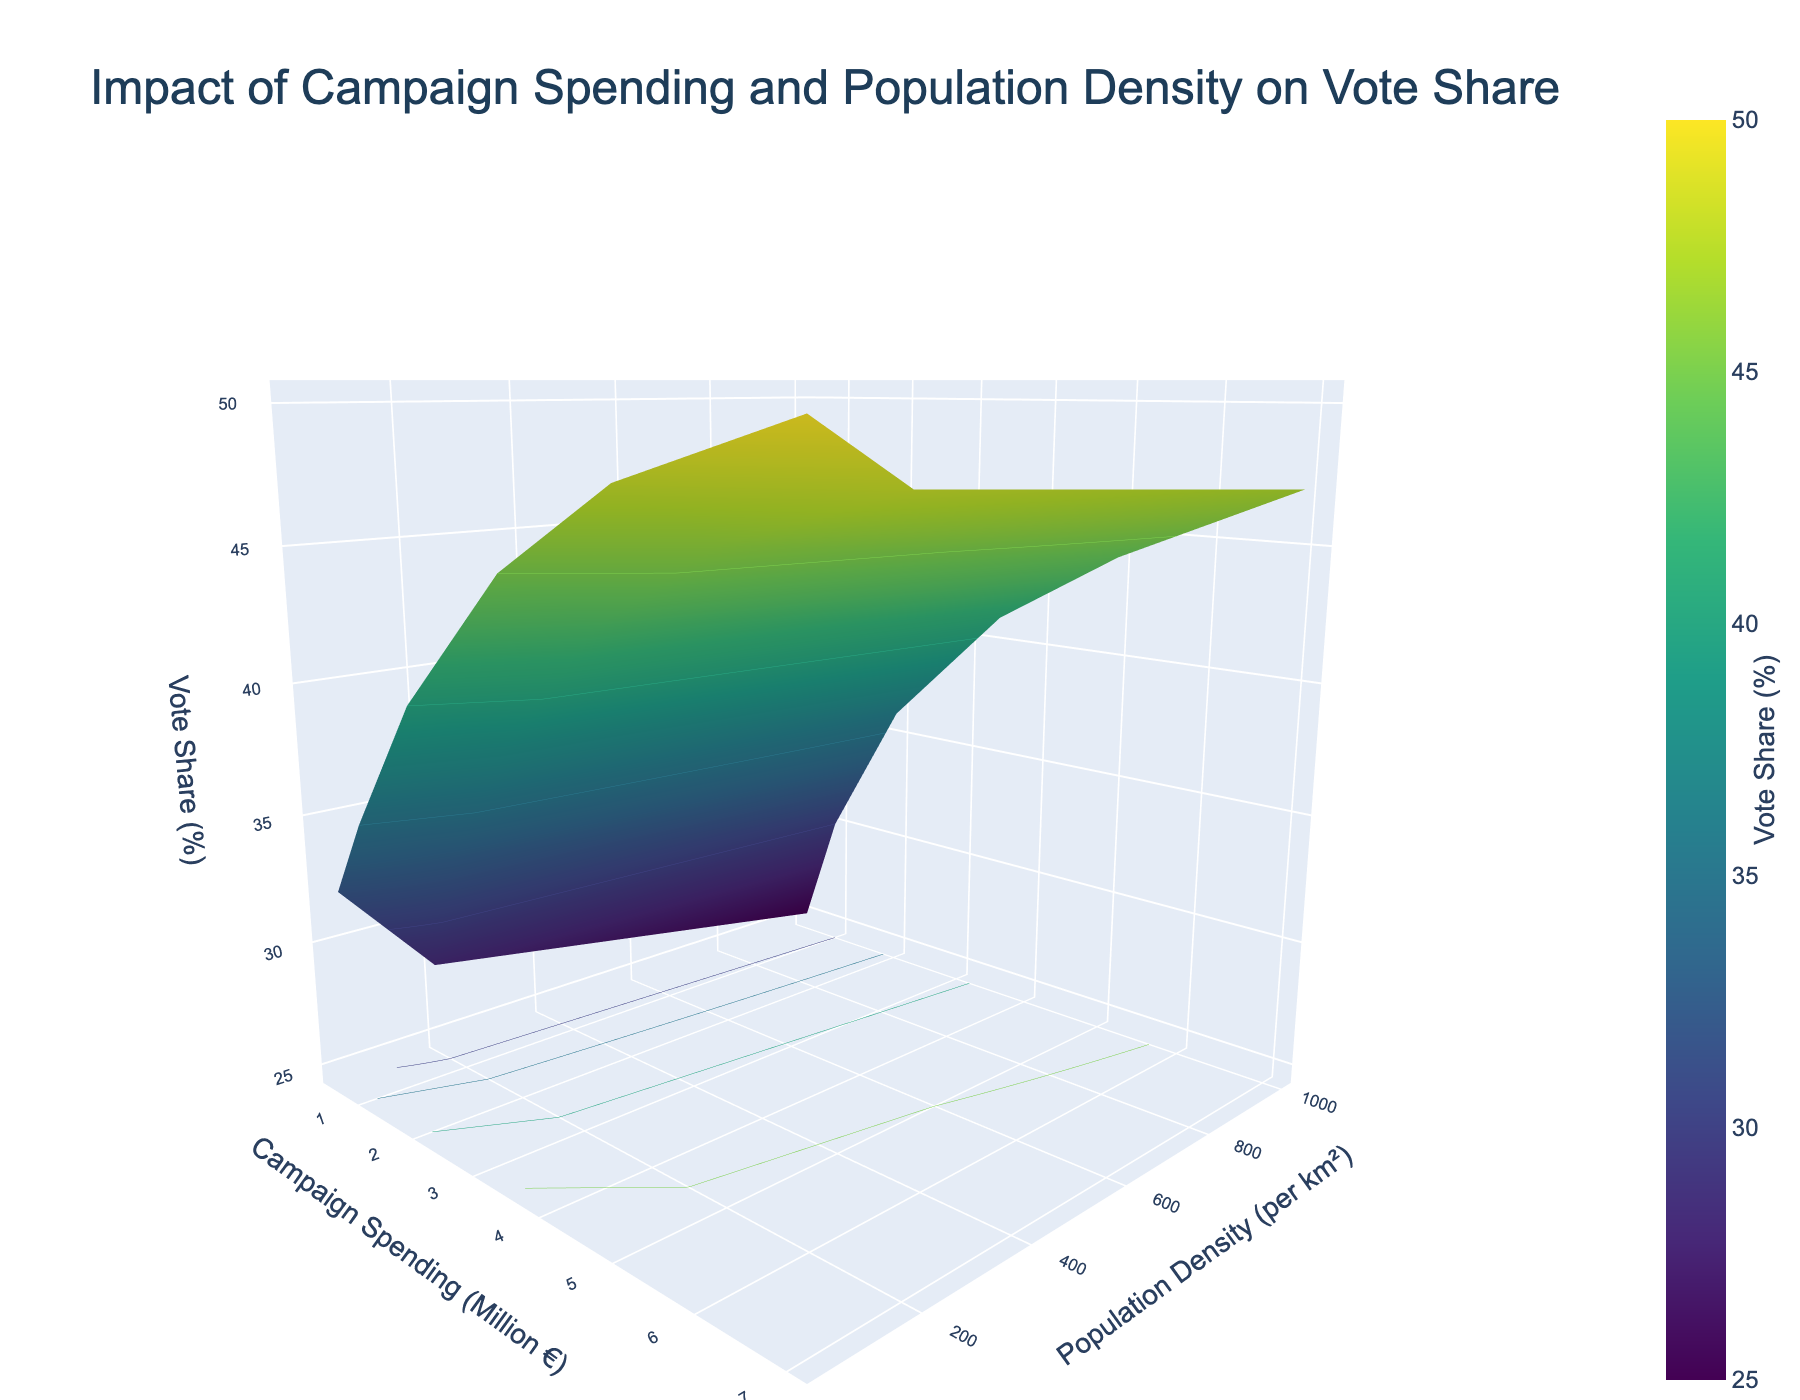What's the title of this figure? The title is displayed at the top of the figure. By reading the title, we can see that it is "Impact of Campaign Spending and Population Density on Vote Share."
Answer: Impact of Campaign Spending and Population Density on Vote Share What do the x-axis, y-axis, and z-axis represent? The x-axis, y-axis, and z-axis titles are found on the figure. The x-axis represents "Campaign Spending (Million €)," the y-axis represents "Population Density (per km²)," and the z-axis represents "Vote Share (%)."
Answer: Campaign Spending, Population Density, Vote Share How does the vote share change with increasing campaign spending for a population density of 50 per km²? By observing the surface plot at a y-axis value (Population Density) of 50, we can follow the trends in the z-axis (Vote Share) as the x-axis (Campaign Spending) increases. The vote share increments significantly as campaign spending rises from 0.5 to 7.0 million euros.
Answer: Increases significantly At which population density does campaign spending have the least impact on vote share? By comparing the slopes of the surface plot along different population densities (y-axis), we see that the changes in the z-axis (Vote Share) for the highest population density of 1000 per km² are more gradual compared to 50 and 200 per km².
Answer: 1000 per km² In which population density are the variations in vote share the highest for varying campaign spending? By observing the variation in z-axis values (Vote Share) as the x-axis (Campaign Spending) changes across different population densities, the density of 50 per km² shows the steepest rise, indicating the highest variation in vote share with changing campaign spending.
Answer: 50 per km² How does vote share compare between the lowest and highest levels of campaign spending at a population density of 200 per km²? At a population density of 200 per km², observe the z-axis values (Vote Share) at the lowest campaign spending of 0.5 million euros and at the highest of 7.0 million euros. Vote share increases from approximately 28% to 48%.
Answer: 28% to 48% Is there a population density where the vote share increases linearly with campaign spending? Examining the shape of the surface plot, a population density of 200 per km² demonstrates a nearly linear increase in vote share from 0.5 to 7.0 million euros of campaign spending when comparing the slopes to others.
Answer: 200 per km² What is the vote share percentage at 3.5 million euros in campaign spending for a population density of 1000 per km²? Trace along the x-axis to 3.5 million euros, then follow the y-axis to 1000 per km², and observe the z-axis value corresponding to this point on the surface plot, which is approximately 41%.
Answer: 41% Which campaign spending level results in the highest vote share at the lowest population density given? At the lowest population density of 50 per km², the highest point on the z-axis (Vote Share) corresponds to the highest x-axis (Campaign Spending) of 7.0 million euros.
Answer: 7.0 million euros What is the difference in vote share at the lowest campaign spending between the highest and lowest population densities? Find the z-axis (Vote Share) values at 0.5 million euros (x-axis) for both 50 and 1000 per km² (y-axis). The difference is between 32% for 50 per km² and 25% for 1000 per km², resulting in a difference of 7%.
Answer: 7% 